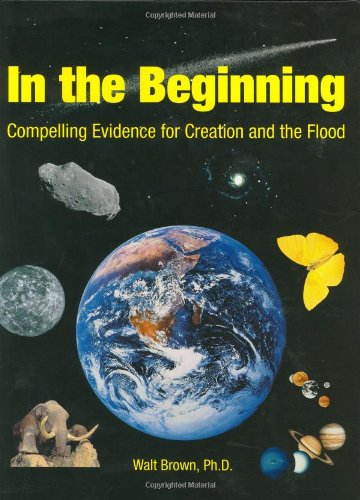Is this christianity book? Yes, this book is deeply rooted in Christian doctrine, discussing creation and the flood from a biblical perspective. 